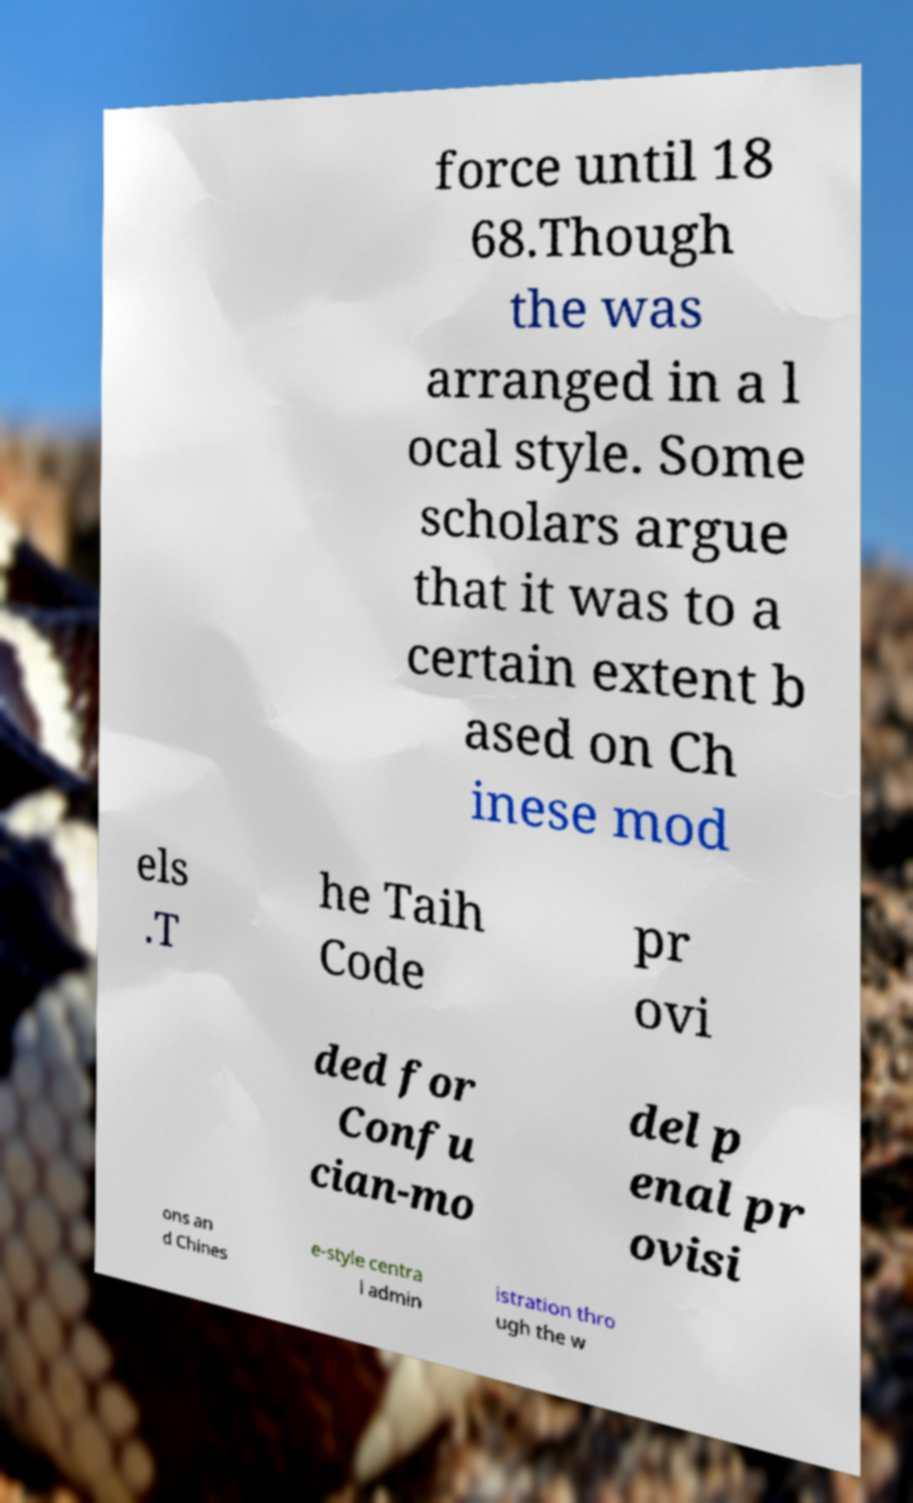Could you extract and type out the text from this image? force until 18 68.Though the was arranged in a l ocal style. Some scholars argue that it was to a certain extent b ased on Ch inese mod els .T he Taih Code pr ovi ded for Confu cian-mo del p enal pr ovisi ons an d Chines e-style centra l admin istration thro ugh the w 